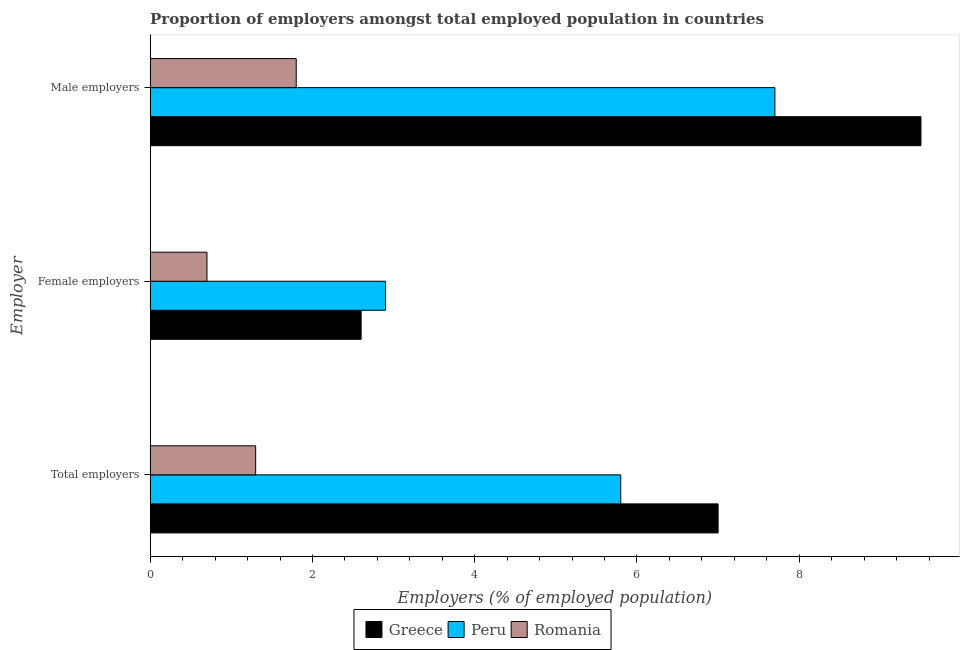How many different coloured bars are there?
Ensure brevity in your answer.  3. How many groups of bars are there?
Offer a very short reply. 3. Are the number of bars per tick equal to the number of legend labels?
Your response must be concise. Yes. How many bars are there on the 1st tick from the top?
Ensure brevity in your answer.  3. What is the label of the 1st group of bars from the top?
Offer a very short reply. Male employers. What is the percentage of female employers in Romania?
Ensure brevity in your answer.  0.7. Across all countries, what is the maximum percentage of total employers?
Give a very brief answer. 7. Across all countries, what is the minimum percentage of female employers?
Give a very brief answer. 0.7. In which country was the percentage of female employers maximum?
Provide a succinct answer. Peru. In which country was the percentage of male employers minimum?
Offer a very short reply. Romania. What is the total percentage of female employers in the graph?
Offer a very short reply. 6.2. What is the difference between the percentage of female employers in Peru and that in Romania?
Your response must be concise. 2.2. What is the difference between the percentage of female employers in Peru and the percentage of male employers in Greece?
Make the answer very short. -6.6. What is the average percentage of female employers per country?
Your answer should be very brief. 2.07. What is the difference between the percentage of total employers and percentage of female employers in Peru?
Make the answer very short. 2.9. What is the ratio of the percentage of total employers in Peru to that in Romania?
Offer a very short reply. 4.46. What is the difference between the highest and the second highest percentage of male employers?
Offer a very short reply. 1.8. What is the difference between the highest and the lowest percentage of total employers?
Make the answer very short. 5.7. What does the 1st bar from the top in Female employers represents?
Provide a short and direct response. Romania. What does the 1st bar from the bottom in Male employers represents?
Your response must be concise. Greece. Is it the case that in every country, the sum of the percentage of total employers and percentage of female employers is greater than the percentage of male employers?
Offer a very short reply. Yes. Are all the bars in the graph horizontal?
Provide a short and direct response. Yes. Are the values on the major ticks of X-axis written in scientific E-notation?
Provide a succinct answer. No. Does the graph contain any zero values?
Offer a very short reply. No. Where does the legend appear in the graph?
Your answer should be compact. Bottom center. How many legend labels are there?
Keep it short and to the point. 3. What is the title of the graph?
Make the answer very short. Proportion of employers amongst total employed population in countries. Does "Pakistan" appear as one of the legend labels in the graph?
Provide a short and direct response. No. What is the label or title of the X-axis?
Ensure brevity in your answer.  Employers (% of employed population). What is the label or title of the Y-axis?
Ensure brevity in your answer.  Employer. What is the Employers (% of employed population) in Peru in Total employers?
Provide a short and direct response. 5.8. What is the Employers (% of employed population) in Romania in Total employers?
Provide a short and direct response. 1.3. What is the Employers (% of employed population) in Greece in Female employers?
Ensure brevity in your answer.  2.6. What is the Employers (% of employed population) of Peru in Female employers?
Offer a terse response. 2.9. What is the Employers (% of employed population) in Romania in Female employers?
Provide a succinct answer. 0.7. What is the Employers (% of employed population) of Peru in Male employers?
Your answer should be very brief. 7.7. What is the Employers (% of employed population) of Romania in Male employers?
Your response must be concise. 1.8. Across all Employer, what is the maximum Employers (% of employed population) of Greece?
Offer a very short reply. 9.5. Across all Employer, what is the maximum Employers (% of employed population) of Peru?
Ensure brevity in your answer.  7.7. Across all Employer, what is the maximum Employers (% of employed population) of Romania?
Your answer should be compact. 1.8. Across all Employer, what is the minimum Employers (% of employed population) of Greece?
Your answer should be very brief. 2.6. Across all Employer, what is the minimum Employers (% of employed population) of Peru?
Give a very brief answer. 2.9. Across all Employer, what is the minimum Employers (% of employed population) in Romania?
Your response must be concise. 0.7. What is the difference between the Employers (% of employed population) of Greece in Total employers and that in Female employers?
Keep it short and to the point. 4.4. What is the difference between the Employers (% of employed population) of Peru in Total employers and that in Female employers?
Your response must be concise. 2.9. What is the difference between the Employers (% of employed population) in Romania in Total employers and that in Female employers?
Your answer should be compact. 0.6. What is the difference between the Employers (% of employed population) of Greece in Total employers and that in Male employers?
Offer a terse response. -2.5. What is the difference between the Employers (% of employed population) of Greece in Female employers and that in Male employers?
Offer a terse response. -6.9. What is the difference between the Employers (% of employed population) of Romania in Female employers and that in Male employers?
Ensure brevity in your answer.  -1.1. What is the difference between the Employers (% of employed population) of Greece in Total employers and the Employers (% of employed population) of Romania in Female employers?
Offer a very short reply. 6.3. What is the difference between the Employers (% of employed population) of Greece in Total employers and the Employers (% of employed population) of Peru in Male employers?
Provide a succinct answer. -0.7. What is the difference between the Employers (% of employed population) of Greece in Total employers and the Employers (% of employed population) of Romania in Male employers?
Give a very brief answer. 5.2. What is the difference between the Employers (% of employed population) in Greece in Female employers and the Employers (% of employed population) in Romania in Male employers?
Provide a short and direct response. 0.8. What is the average Employers (% of employed population) of Greece per Employer?
Offer a very short reply. 6.37. What is the average Employers (% of employed population) of Peru per Employer?
Your response must be concise. 5.47. What is the average Employers (% of employed population) of Romania per Employer?
Keep it short and to the point. 1.27. What is the difference between the Employers (% of employed population) of Greece and Employers (% of employed population) of Romania in Total employers?
Provide a short and direct response. 5.7. What is the difference between the Employers (% of employed population) of Peru and Employers (% of employed population) of Romania in Total employers?
Offer a terse response. 4.5. What is the difference between the Employers (% of employed population) of Greece and Employers (% of employed population) of Romania in Female employers?
Your response must be concise. 1.9. What is the difference between the Employers (% of employed population) in Peru and Employers (% of employed population) in Romania in Male employers?
Keep it short and to the point. 5.9. What is the ratio of the Employers (% of employed population) in Greece in Total employers to that in Female employers?
Provide a succinct answer. 2.69. What is the ratio of the Employers (% of employed population) of Romania in Total employers to that in Female employers?
Ensure brevity in your answer.  1.86. What is the ratio of the Employers (% of employed population) in Greece in Total employers to that in Male employers?
Keep it short and to the point. 0.74. What is the ratio of the Employers (% of employed population) in Peru in Total employers to that in Male employers?
Give a very brief answer. 0.75. What is the ratio of the Employers (% of employed population) of Romania in Total employers to that in Male employers?
Make the answer very short. 0.72. What is the ratio of the Employers (% of employed population) in Greece in Female employers to that in Male employers?
Your answer should be very brief. 0.27. What is the ratio of the Employers (% of employed population) of Peru in Female employers to that in Male employers?
Provide a succinct answer. 0.38. What is the ratio of the Employers (% of employed population) of Romania in Female employers to that in Male employers?
Keep it short and to the point. 0.39. What is the difference between the highest and the second highest Employers (% of employed population) in Greece?
Your answer should be compact. 2.5. What is the difference between the highest and the lowest Employers (% of employed population) in Greece?
Provide a short and direct response. 6.9. What is the difference between the highest and the lowest Employers (% of employed population) in Peru?
Give a very brief answer. 4.8. What is the difference between the highest and the lowest Employers (% of employed population) in Romania?
Provide a succinct answer. 1.1. 